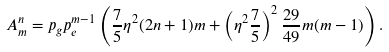Convert formula to latex. <formula><loc_0><loc_0><loc_500><loc_500>A _ { m } ^ { n } = p _ { g } p _ { e } ^ { m - 1 } \left ( \frac { 7 } { 5 } \eta ^ { 2 } ( 2 n + 1 ) m + \left ( \eta ^ { 2 } \frac { 7 } { 5 } \right ) ^ { 2 } \frac { 2 9 } { 4 9 } m ( m - 1 ) \right ) .</formula> 